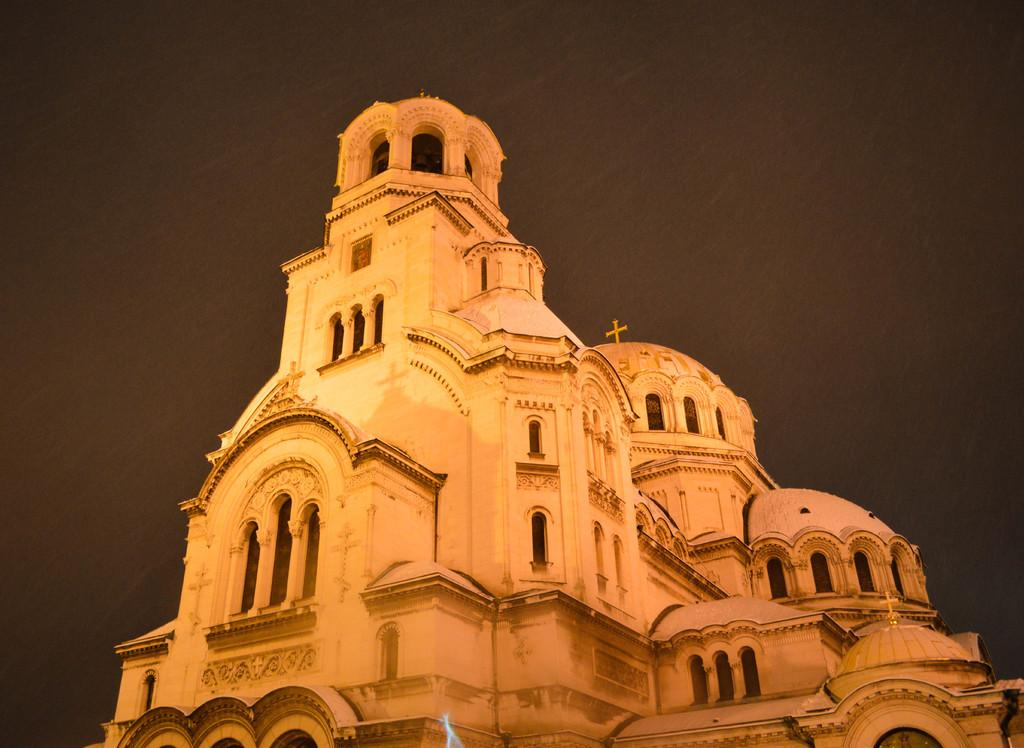What type of structure is in the image? There is a building in the image. What symbol can be seen on the building? The building has a cross symbol on it. What feature is common to many buildings and is present on this one? There are windows on the building. What can be seen in the background of the image? The sky is visible in the background of the image. What language is spoken by the building in the image? Buildings do not speak languages; they are inanimate objects. 